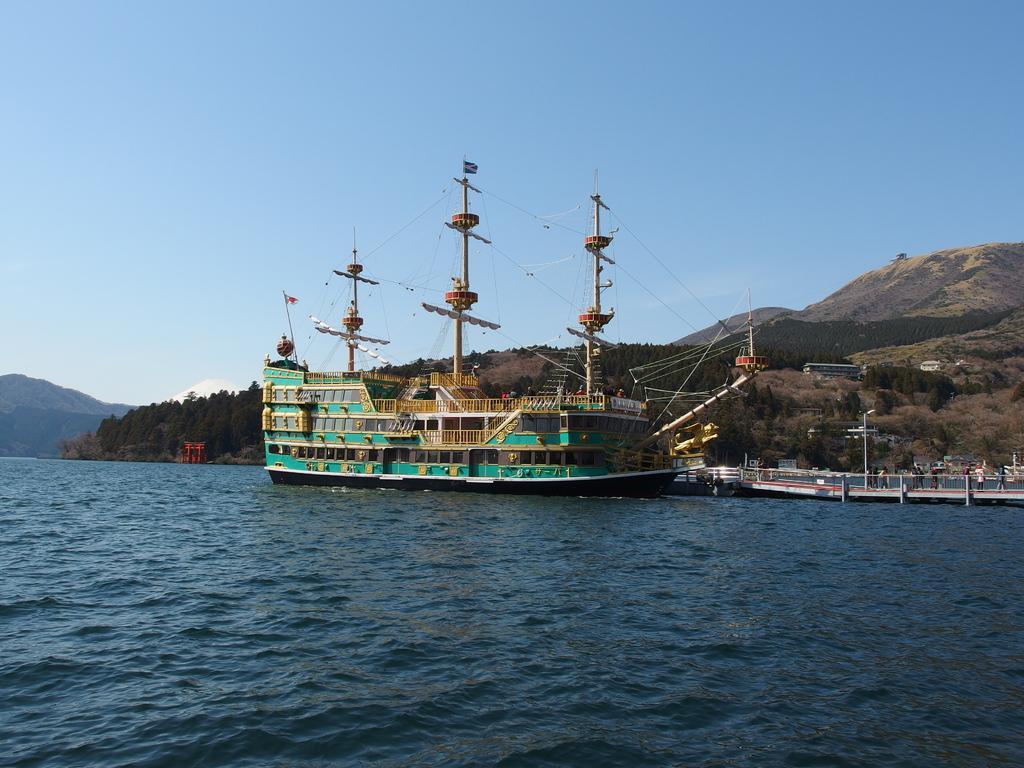Describe this image in one or two sentences. In the picture we can see water which is blue in color and in it we can see a ship with poles and wires to it and beside it we can see some boats and behind it we can see some hills which are covered with trees and some part is covered with grass surface and in the background we can see a sky. 